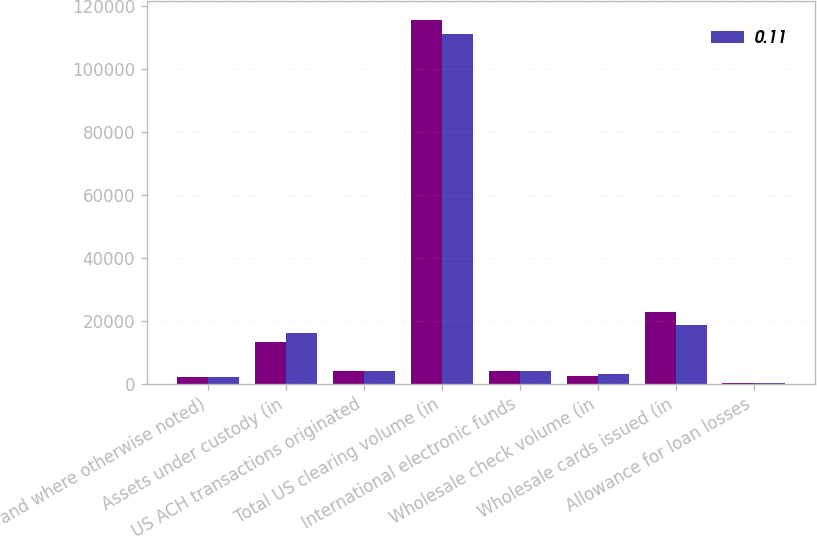<chart> <loc_0><loc_0><loc_500><loc_500><stacked_bar_chart><ecel><fcel>and where otherwise noted)<fcel>Assets under custody (in<fcel>US ACH transactions originated<fcel>Total US clearing volume (in<fcel>International electronic funds<fcel>Wholesale check volume (in<fcel>Wholesale cards issued (in<fcel>Allowance for loan losses<nl><fcel>nan<fcel>2008<fcel>13205<fcel>4000<fcel>115742<fcel>3935<fcel>2408<fcel>22784<fcel>74<nl><fcel>0.11<fcel>2007<fcel>15946<fcel>3870<fcel>111036<fcel>3935<fcel>2925<fcel>18722<fcel>18<nl></chart> 